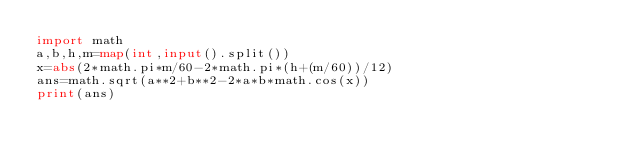Convert code to text. <code><loc_0><loc_0><loc_500><loc_500><_Python_>import math
a,b,h,m=map(int,input().split())
x=abs(2*math.pi*m/60-2*math.pi*(h+(m/60))/12)
ans=math.sqrt(a**2+b**2-2*a*b*math.cos(x))
print(ans)</code> 